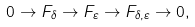Convert formula to latex. <formula><loc_0><loc_0><loc_500><loc_500>0 \to F _ { \delta } \to F _ { \varepsilon } \to F _ { \delta , \varepsilon } \to 0 ,</formula> 